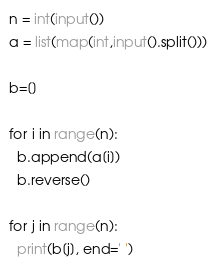Convert code to text. <code><loc_0><loc_0><loc_500><loc_500><_Python_>n = int(input())
a = list(map(int,input().split()))

b=[]

for i in range(n):
  b.append(a[i])
  b.reverse()

for j in range(n):
  print(b[j], end=' ')</code> 